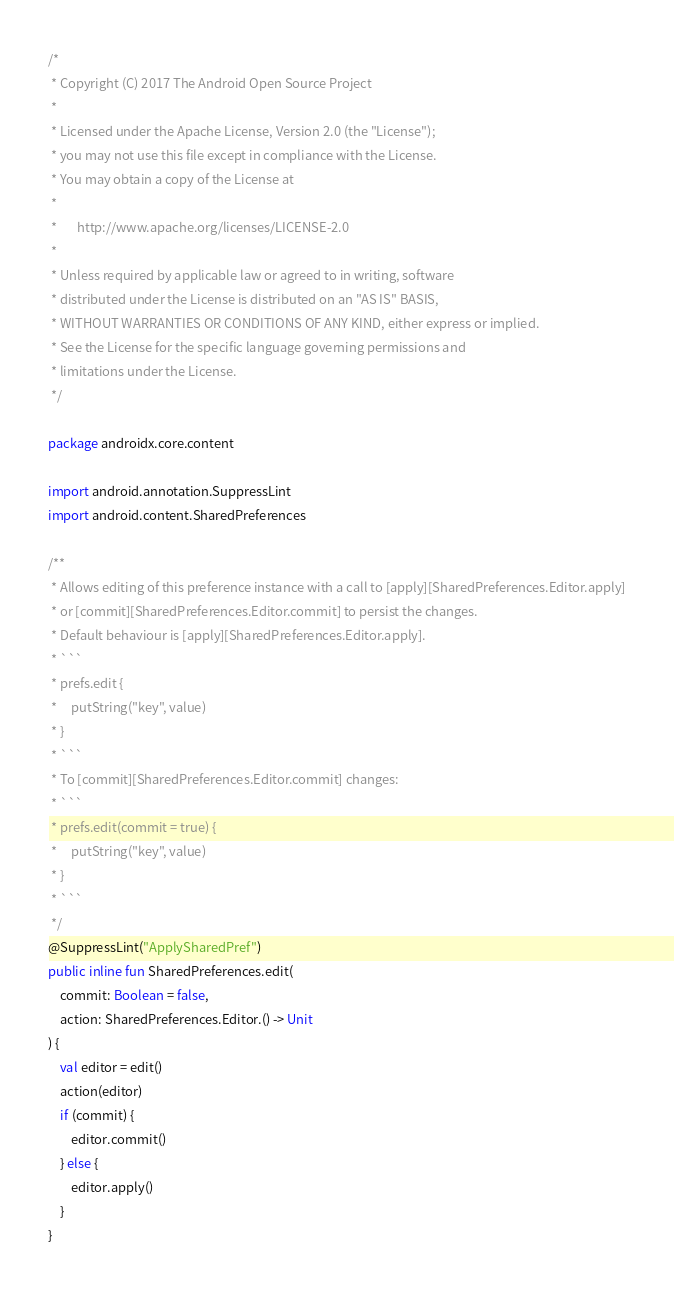<code> <loc_0><loc_0><loc_500><loc_500><_Kotlin_>/*
 * Copyright (C) 2017 The Android Open Source Project
 *
 * Licensed under the Apache License, Version 2.0 (the "License");
 * you may not use this file except in compliance with the License.
 * You may obtain a copy of the License at
 *
 *       http://www.apache.org/licenses/LICENSE-2.0
 *
 * Unless required by applicable law or agreed to in writing, software
 * distributed under the License is distributed on an "AS IS" BASIS,
 * WITHOUT WARRANTIES OR CONDITIONS OF ANY KIND, either express or implied.
 * See the License for the specific language governing permissions and
 * limitations under the License.
 */

package androidx.core.content

import android.annotation.SuppressLint
import android.content.SharedPreferences

/**
 * Allows editing of this preference instance with a call to [apply][SharedPreferences.Editor.apply]
 * or [commit][SharedPreferences.Editor.commit] to persist the changes.
 * Default behaviour is [apply][SharedPreferences.Editor.apply].
 * ```
 * prefs.edit {
 *     putString("key", value)
 * }
 * ```
 * To [commit][SharedPreferences.Editor.commit] changes:
 * ```
 * prefs.edit(commit = true) {
 *     putString("key", value)
 * }
 * ```
 */
@SuppressLint("ApplySharedPref")
public inline fun SharedPreferences.edit(
    commit: Boolean = false,
    action: SharedPreferences.Editor.() -> Unit
) {
    val editor = edit()
    action(editor)
    if (commit) {
        editor.commit()
    } else {
        editor.apply()
    }
}
</code> 